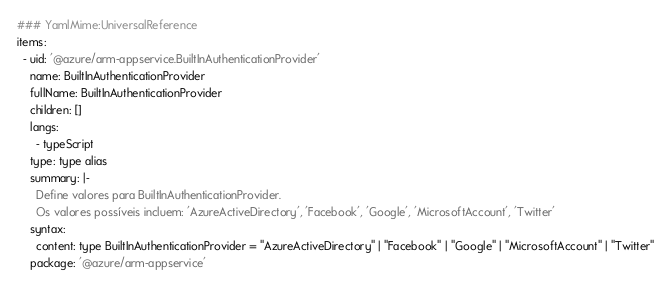<code> <loc_0><loc_0><loc_500><loc_500><_YAML_>### YamlMime:UniversalReference
items:
  - uid: '@azure/arm-appservice.BuiltInAuthenticationProvider'
    name: BuiltInAuthenticationProvider
    fullName: BuiltInAuthenticationProvider
    children: []
    langs:
      - typeScript
    type: type alias
    summary: |-
      Define valores para BuiltInAuthenticationProvider.
      Os valores possíveis incluem: 'AzureActiveDirectory', 'Facebook', 'Google', 'MicrosoftAccount', 'Twitter'
    syntax:
      content: type BuiltInAuthenticationProvider = "AzureActiveDirectory" | "Facebook" | "Google" | "MicrosoftAccount" | "Twitter"
    package: '@azure/arm-appservice'</code> 